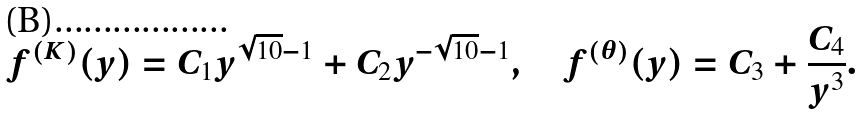<formula> <loc_0><loc_0><loc_500><loc_500>f ^ { ( K ) } ( y ) = C _ { 1 } y ^ { \sqrt { 1 0 } - 1 } + C _ { 2 } y ^ { - \sqrt { 1 0 } - 1 } , \quad f ^ { ( \theta ) } ( y ) = C _ { 3 } + \frac { C _ { 4 } } { y ^ { 3 } } .</formula> 